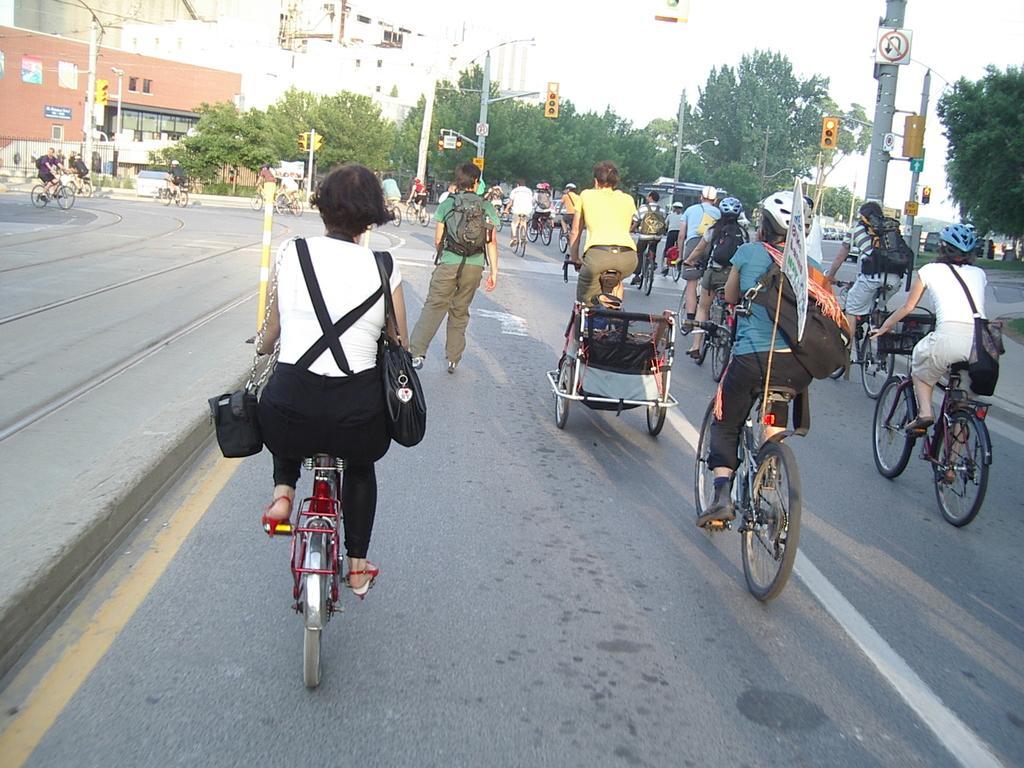Describe this image in one or two sentences. In this image we can see these people are riding their bicycles on the road. Here we can see this person is walking on the road. In the background, we can see caution boards and traffic signals to the pole. Here we can see trees and buildings. 